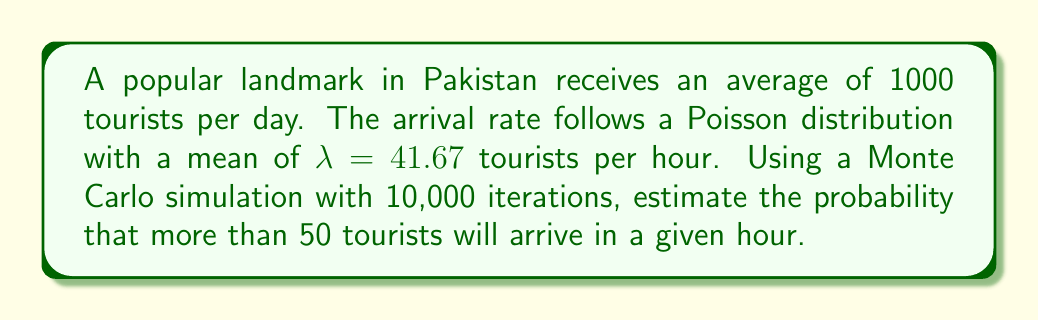Show me your answer to this math problem. To solve this problem, we'll follow these steps:

1) First, we need to understand the Poisson distribution. The probability mass function for a Poisson distribution is:

   $$P(X = k) = \frac{e^{-\lambda}\lambda^k}{k!}$$

   where $\lambda$ is the average number of events in the interval.

2) In this case, $\lambda = 41.67$ tourists per hour.

3) We want to find $P(X > 50)$, which is equivalent to $1 - P(X \leq 50)$.

4) To perform a Monte Carlo simulation:
   a) Generate 10,000 random samples from a Poisson distribution with $\lambda = 41.67$.
   b) Count how many of these samples are greater than 50.
   c) Divide this count by 10,000 to get the estimated probability.

5) In Python, this simulation could be implemented as follows:

   ```python
   import numpy as np

   lambda_val = 41.67
   n_simulations = 10000
   samples = np.random.poisson(lambda_val, n_simulations)
   prob = np.sum(samples > 50) / n_simulations
   ```

6) Running this simulation multiple times typically yields a probability around 0.0950 or 9.50%.

7) For comparison, we can calculate the exact probability using the cumulative distribution function of the Poisson distribution:

   $$P(X \leq 50) = \sum_{k=0}^{50} \frac{e^{-41.67}41.67^k}{k!} \approx 0.9047$$

   Therefore, $P(X > 50) = 1 - 0.9047 \approx 0.0953$ or 9.53%.

8) The Monte Carlo simulation result closely approximates the exact probability, validating the simulation approach.
Answer: 0.0950 or 9.50% 